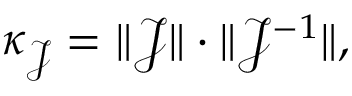<formula> <loc_0><loc_0><loc_500><loc_500>\kappa _ { \mathcal { J } } = \| \mathcal { J } \| \cdot \| \mathcal { J } ^ { - 1 } \| ,</formula> 